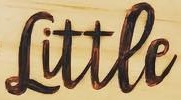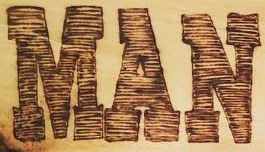What text is displayed in these images sequentially, separated by a semicolon? Littee; MAN 